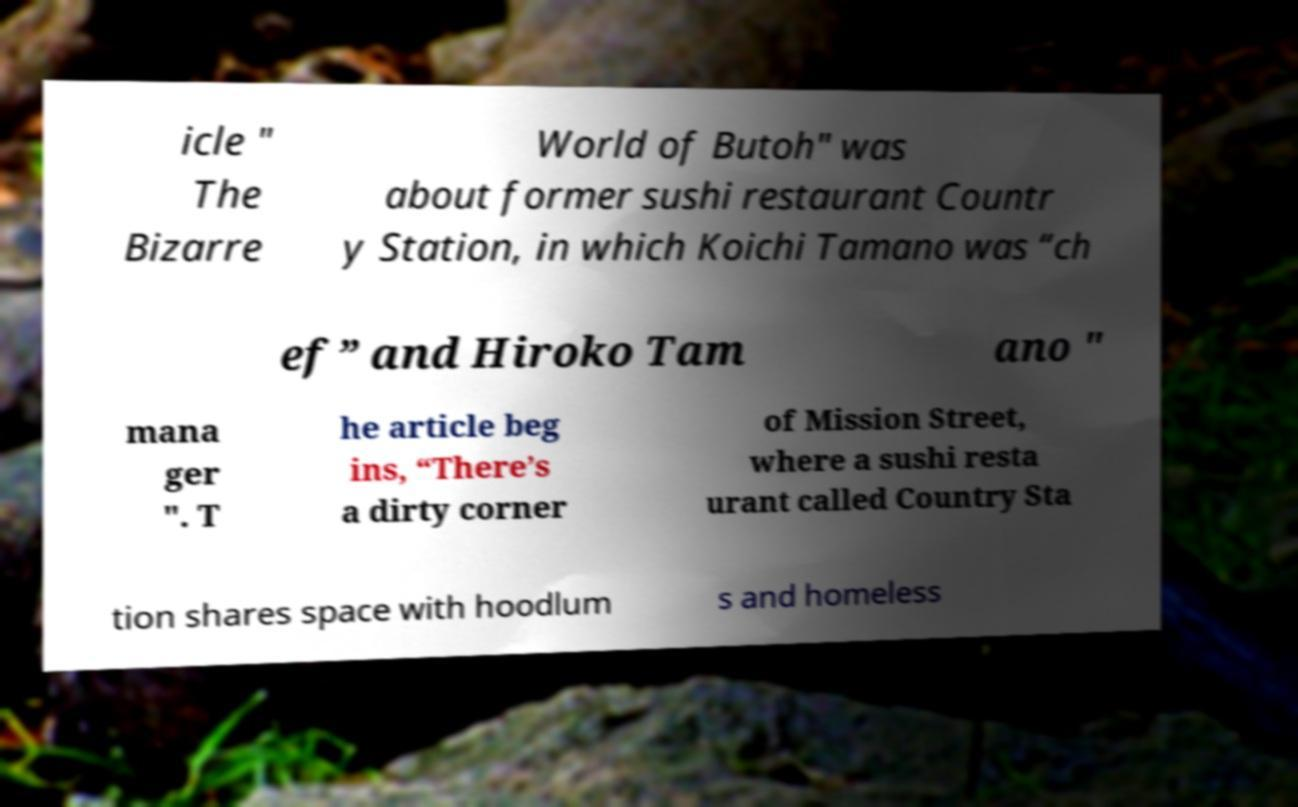Please read and relay the text visible in this image. What does it say? icle " The Bizarre World of Butoh" was about former sushi restaurant Countr y Station, in which Koichi Tamano was “ch ef” and Hiroko Tam ano " mana ger ". T he article beg ins, “There’s a dirty corner of Mission Street, where a sushi resta urant called Country Sta tion shares space with hoodlum s and homeless 